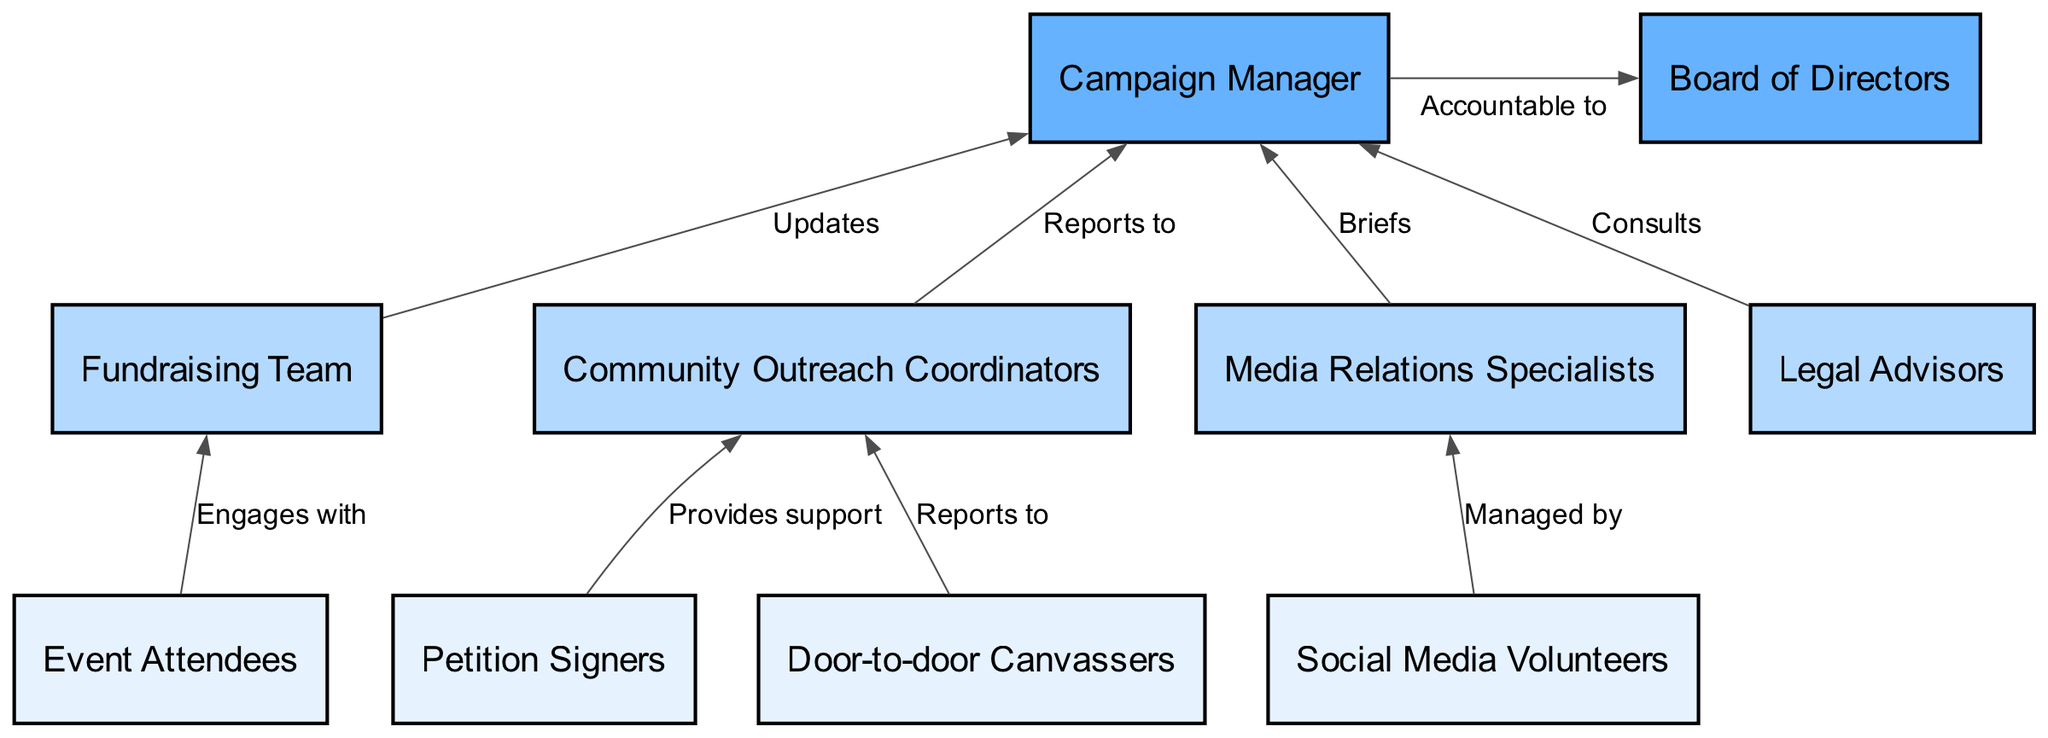What are the bottom-level roles in the campaign? The bottom level of the flow chart consists of four roles: Door-to-door Canvassers, Petition Signers, Social Media Volunteers, and Event Attendees.
Answer: Door-to-door Canvassers, Petition Signers, Social Media Volunteers, Event Attendees How many middle-level roles are there? The flow chart lists four middle-level roles: Community Outreach Coordinators, Fundraising Team, Media Relations Specialists, and Legal Advisors. Therefore, there are four roles.
Answer: 4 Who does the Fundraising Team report to? According to the connections in the chart, the Fundraising Team updates the Campaign Manager, indicating a reporting relationship.
Answer: Campaign Manager Which group engages with the Fundraising Team? The flow chart shows that Event Attendees engage with the Fundraising Team, as indicated in the connections section.
Answer: Event Attendees How many connections are there in total? By counting the connections listed in the data, there are eight connections depicted in the flow chart.
Answer: 8 What is the role above the Community Outreach Coordinators? The flow chart indicates that the Community Outreach Coordinators report to the Campaign Manager, which means the Campaign Manager is the role above them.
Answer: Campaign Manager What is the highest leadership role in the organization? The highest leadership role in the flow chart that is specified is the Board of Directors, as it is placed above the Campaign Manager in the hierarchy.
Answer: Board of Directors What do Social Media Volunteers manage? The flow chart specifies that Social Media Volunteers are managed by Media Relations Specialists, indicating their hierarchical relationship.
Answer: Media Relations Specialists How does the Campaign Manager relate to the Board of Directors? The Campaign Manager is accountable to the Board of Directors, establishing a direct link of responsibility from the Campaign Manager to the Board.
Answer: Accountable to 